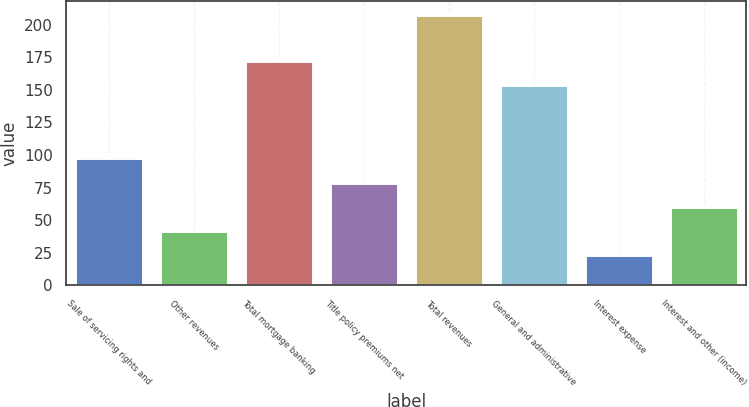<chart> <loc_0><loc_0><loc_500><loc_500><bar_chart><fcel>Sale of servicing rights and<fcel>Other revenues<fcel>Total mortgage banking<fcel>Title policy premiums net<fcel>Total revenues<fcel>General and administrative<fcel>Interest expense<fcel>Interest and other (income)<nl><fcel>97.8<fcel>42.01<fcel>172.21<fcel>78.83<fcel>207.7<fcel>153.8<fcel>23.6<fcel>60.42<nl></chart> 